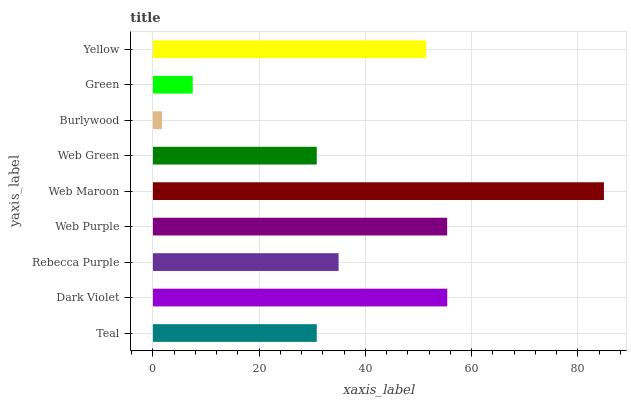Is Burlywood the minimum?
Answer yes or no. Yes. Is Web Maroon the maximum?
Answer yes or no. Yes. Is Dark Violet the minimum?
Answer yes or no. No. Is Dark Violet the maximum?
Answer yes or no. No. Is Dark Violet greater than Teal?
Answer yes or no. Yes. Is Teal less than Dark Violet?
Answer yes or no. Yes. Is Teal greater than Dark Violet?
Answer yes or no. No. Is Dark Violet less than Teal?
Answer yes or no. No. Is Rebecca Purple the high median?
Answer yes or no. Yes. Is Rebecca Purple the low median?
Answer yes or no. Yes. Is Burlywood the high median?
Answer yes or no. No. Is Green the low median?
Answer yes or no. No. 